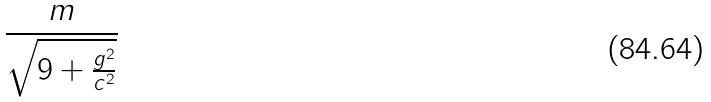Convert formula to latex. <formula><loc_0><loc_0><loc_500><loc_500>\frac { m } { \sqrt { 9 + \frac { g ^ { 2 } } { c ^ { 2 } } } }</formula> 